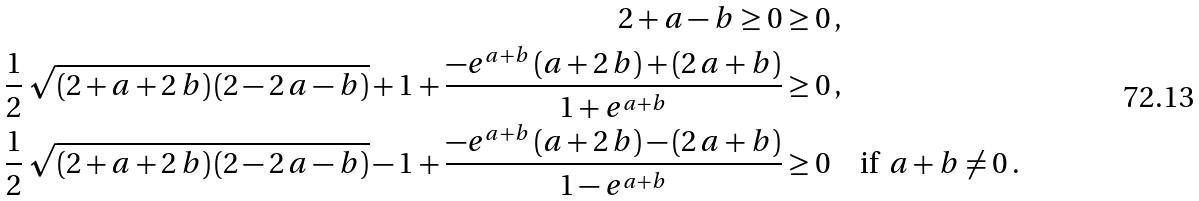<formula> <loc_0><loc_0><loc_500><loc_500>2 + a - b \geq 0 & \geq 0 \, , \\ \frac { 1 } { 2 } \, \sqrt { \left ( 2 + a + 2 \, b \right ) \left ( 2 - 2 \, a - b \right ) } + 1 + \frac { - e ^ { a + b } \left ( a + 2 \, b \right ) + \left ( 2 \, a + b \right ) } { 1 + e ^ { a + b } } & \geq 0 \, , \\ \frac { 1 } { 2 } \, \sqrt { \left ( 2 + a + 2 \, b \right ) \left ( 2 - 2 \, a - b \right ) } - 1 + \frac { - e ^ { a + b } \left ( a + 2 \, b \right ) - \left ( 2 \, a + b \right ) } { 1 - e ^ { a + b } } & \geq 0 \quad \text {if } \, a + b \neq 0 \, .</formula> 